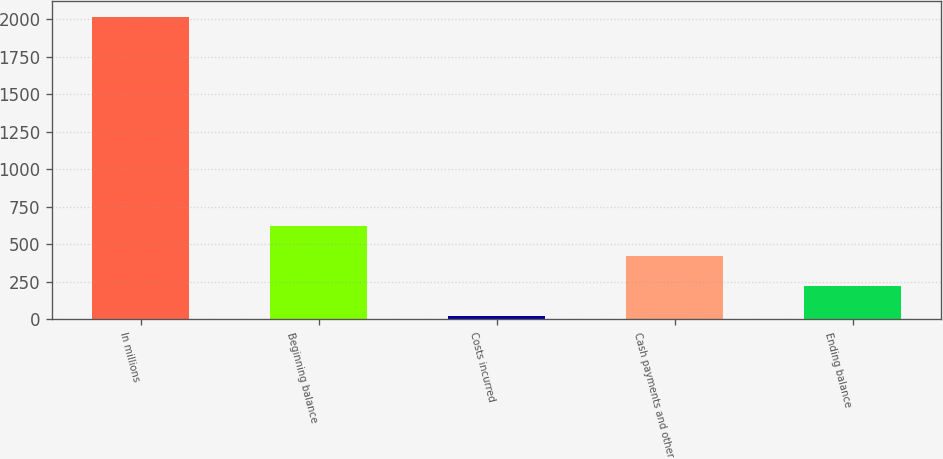Convert chart to OTSL. <chart><loc_0><loc_0><loc_500><loc_500><bar_chart><fcel>In millions<fcel>Beginning balance<fcel>Costs incurred<fcel>Cash payments and other<fcel>Ending balance<nl><fcel>2016<fcel>621.95<fcel>24.5<fcel>422.8<fcel>223.65<nl></chart> 